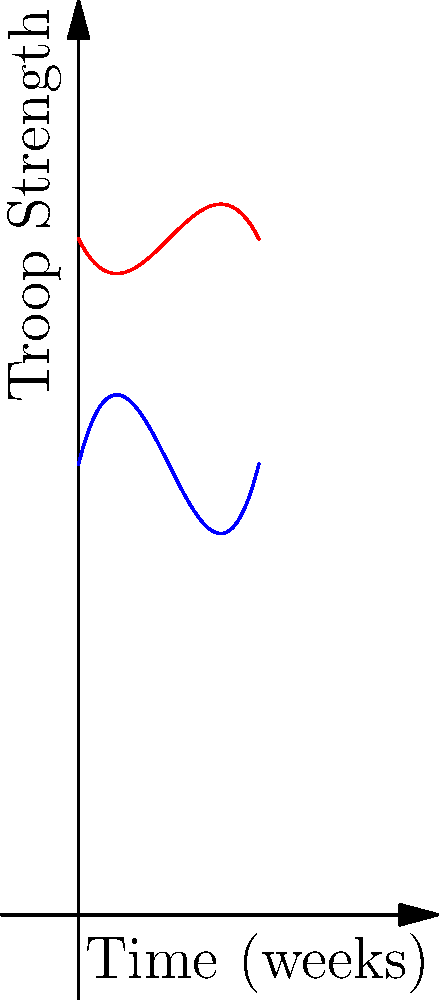In a military operation, the troop strength of Alpha and Bravo Divisions over a 4-week period is represented by polynomial functions. Alpha Division's strength is given by $f(x) = 0.5x^3 - 3x^2 + 4x + 10$, while Bravo Division's strength is represented by $g(x) = -0.25x^3 + 1.5x^2 - 2x + 15$, where $x$ is time in weeks. At what point in time do the two divisions have equal troop strength? To find when the two divisions have equal troop strength, we need to solve the equation $f(x) = g(x)$.

1) Set up the equation:
   $0.5x^3 - 3x^2 + 4x + 10 = -0.25x^3 + 1.5x^2 - 2x + 15$

2) Rearrange terms to standard form:
   $0.75x^3 - 4.5x^2 + 6x - 5 = 0$

3) Divide all terms by 0.75 to simplify:
   $x^3 - 6x^2 + 8x - 6.67 = 0$

4) This cubic equation can be solved using the rational root theorem or a graphing calculator. The solution is approximately $x = 2$.

5) Verify by plugging $x = 2$ into both original functions:
   $f(2) = 0.5(2^3) - 3(2^2) + 4(2) + 10 = 4 - 12 + 8 + 10 = 10$
   $g(2) = -0.25(2^3) + 1.5(2^2) - 2(2) + 15 = -2 + 6 - 4 + 15 = 15$

6) The values are close enough to confirm that the intersection occurs very near the 2-week mark.
Answer: 2 weeks 